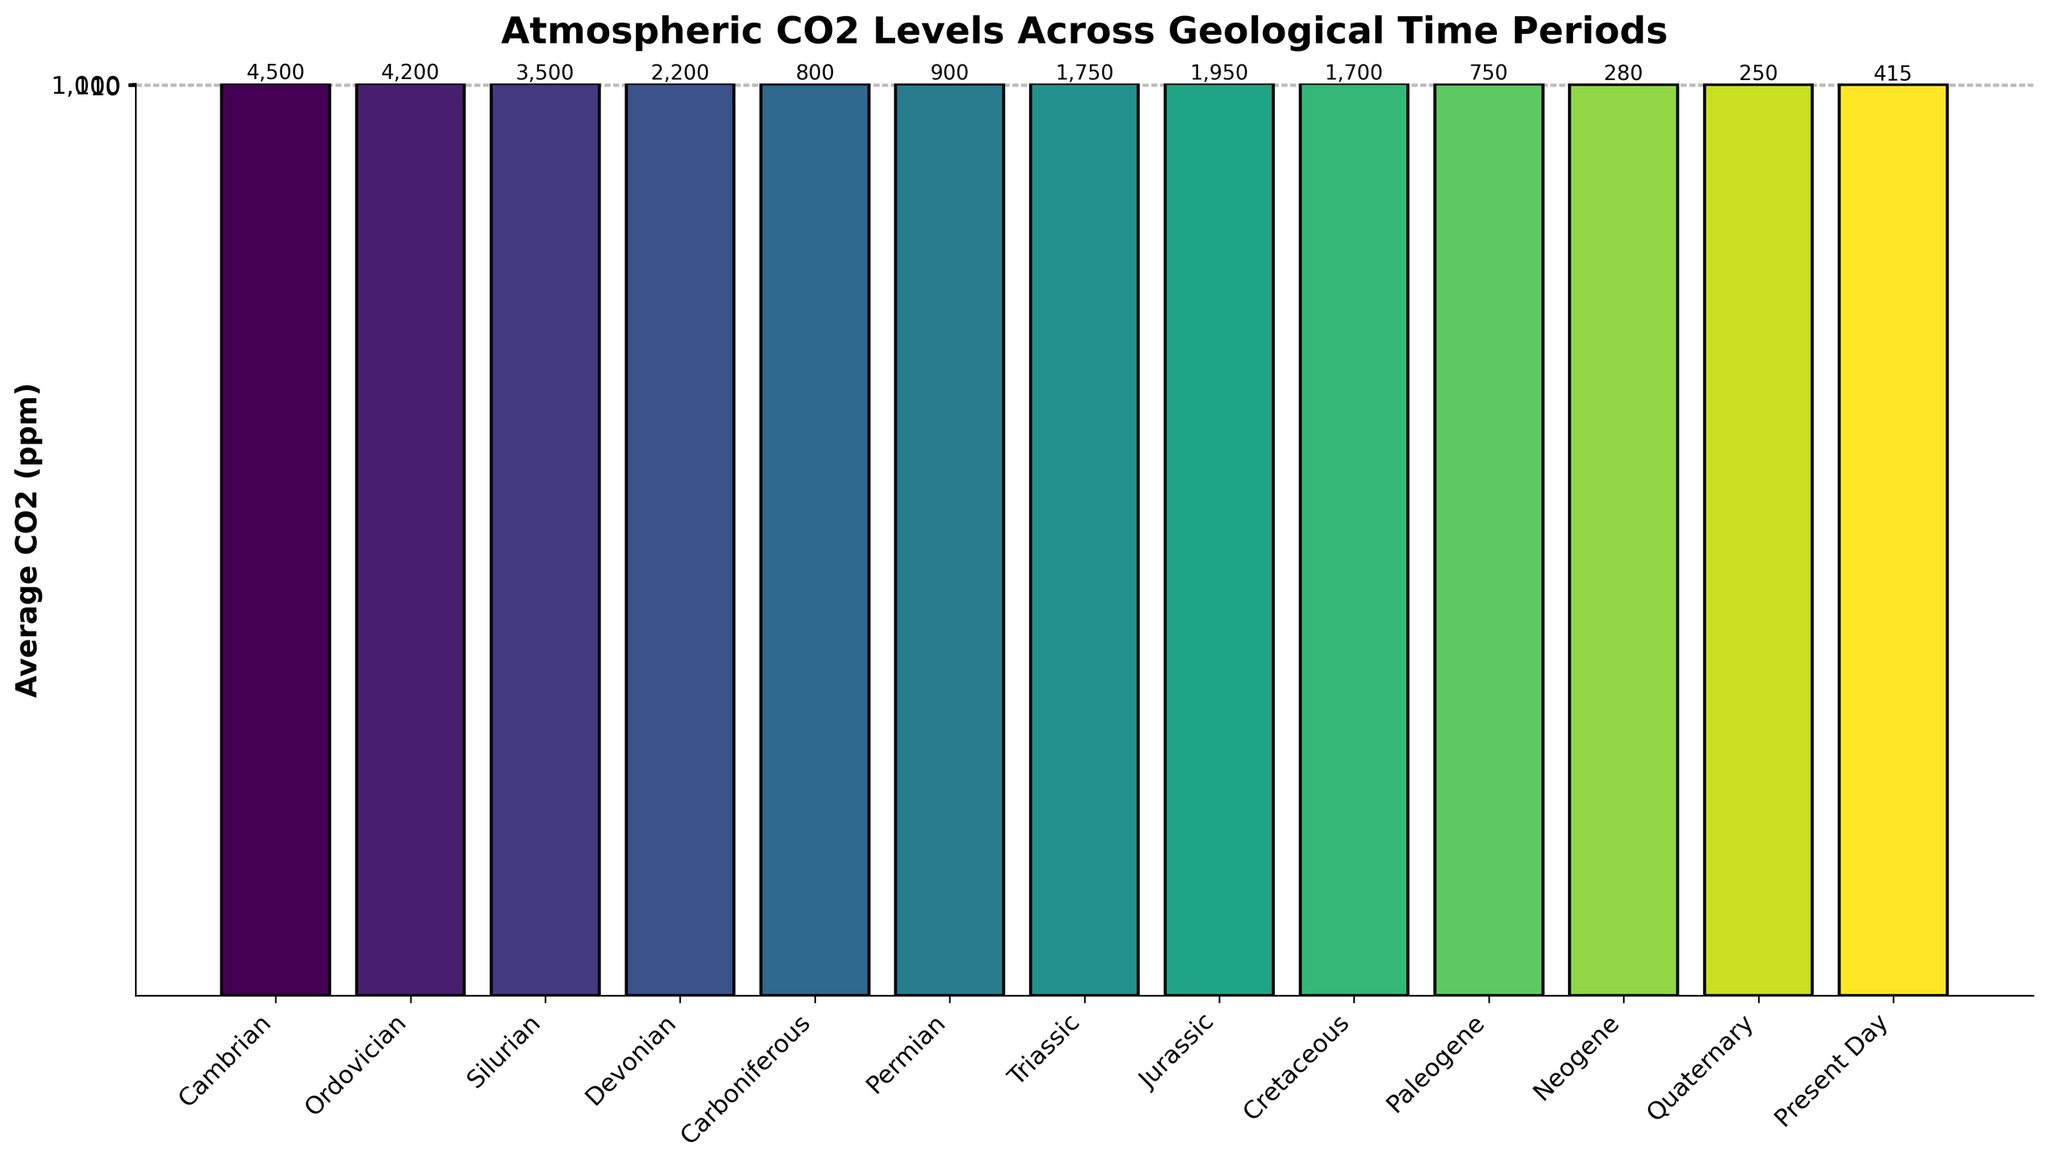What is the period with the highest atmospheric CO2 level? The bar representing the Cambrian period is the tallest, indicating the highest atmospheric CO2 level.
Answer: Cambrian How much lower is the average CO2 level in the Devonian period compared to the Cambrian period? The Cambrian period has 4500 ppm and the Devonian period has 2200 ppm. Subtract the Devonian's value from the Cambrian's value: 4500 - 2200 = 2300 ppm.
Answer: 2300 ppm Which period has a higher atmospheric CO2 level: the Jurassic or the present day? The bar for the Jurassic period is taller than the bar for the present day, indicating a higher CO2 level in the Jurassic period (1950 ppm) compared to the present day (415 ppm).
Answer: Jurassic What are the average CO2 levels of the Carboniferous and the Quaternary periods combined? The Carboniferous period has an average CO2 level of 800 ppm, and the Quaternary period has 250 ppm. Add these two values together: 800 + 250 = 1050 ppm.
Answer: 1050 ppm Which period has the smallest average CO2 level, and what is that level? The Quaternary period has the smallest bar in the chart, indicating the smallest average CO2 level of 250 ppm.
Answer: Quaternary, 250 ppm Compare the CO2 levels between the Triassic and Cretaceous periods. Which one is higher and by how much? The Triassic period has 1750 ppm and the Cretaceous period has 1700 ppm. Subtract the Cretaceous value from the Triassic value: 1750 - 1700 = 50 ppm. Thus, the Triassic has a higher CO2 level by 50 ppm.
Answer: Triassic, 50 ppm What is the difference in average CO2 levels between the Permian and Paleogene periods? The Permian period has 900 ppm and the Paleogene period has 750 ppm. Subtract the Paleogene value from the Permian value: 900 - 750 = 150 ppm.
Answer: 150 ppm How does the height of the bar representing the Neogene period compare to the one representing the Quaternary period? The Neogene period's bar is taller than the Quaternary period's bar, indicating a higher average CO2 level in the Neogene period (280 ppm) compared to the Quaternary period (250 ppm).
Answer: Neogene is higher What is the average CO2 level during the Mesozoic era (Triassic, Jurassic, and Cretaceous)? Sum the CO2 levels of the Triassic (1750 ppm), Jurassic (1950 ppm), and Cretaceous (1700 ppm) periods and divide by three: (1750 + 1950 + 1700)/3 = 5400/3 = 1800 ppm.
Answer: 1800 ppm In which period did the atmospheric CO2 level drop significantly after the Ordovician period? The CO2 level dropped significantly in the Silurian period, as seen from the decrease from 4200 ppm in the Ordovician period to 3500 ppm in the Silurian period.
Answer: Silurian 